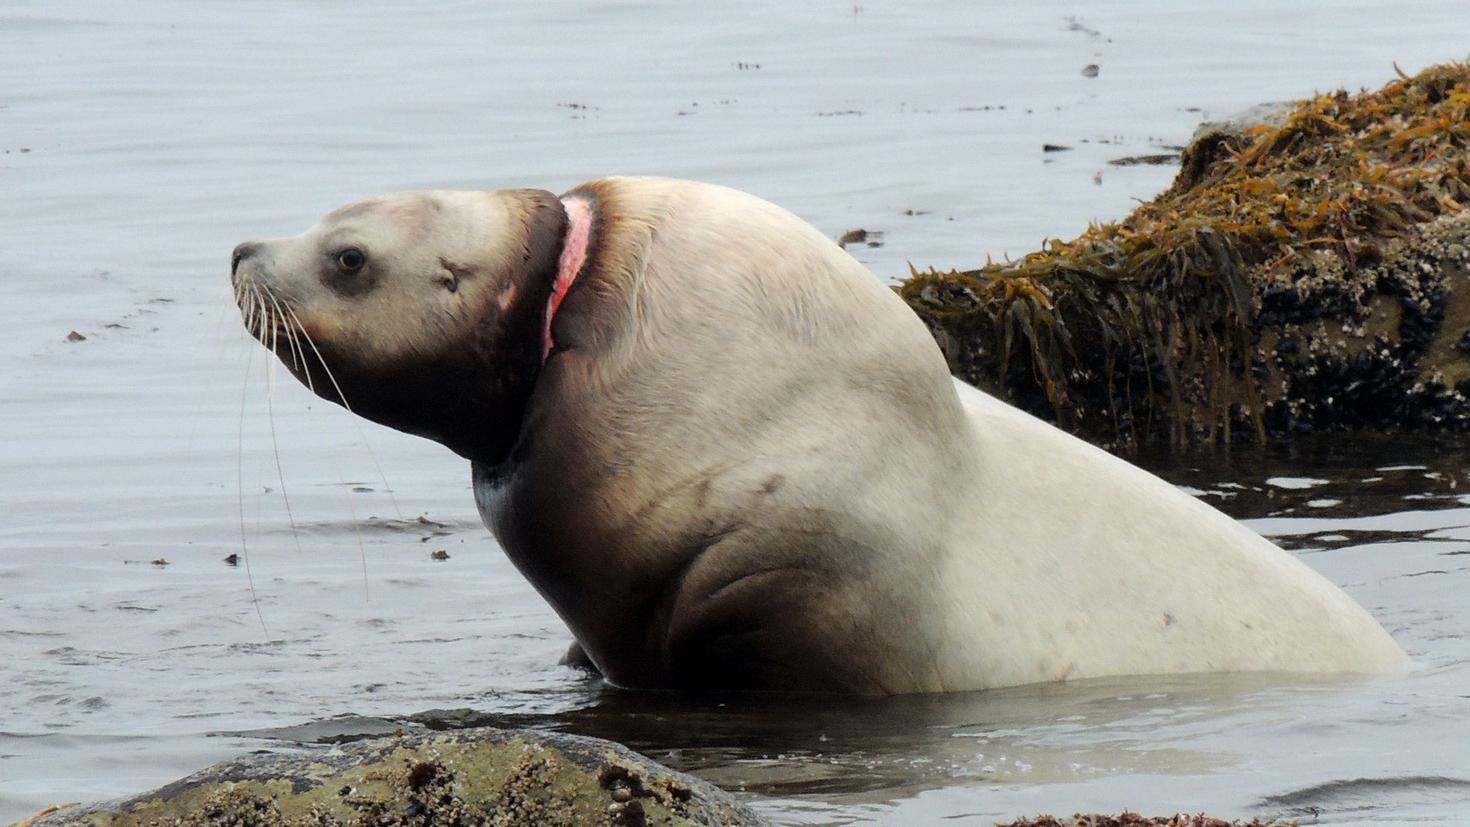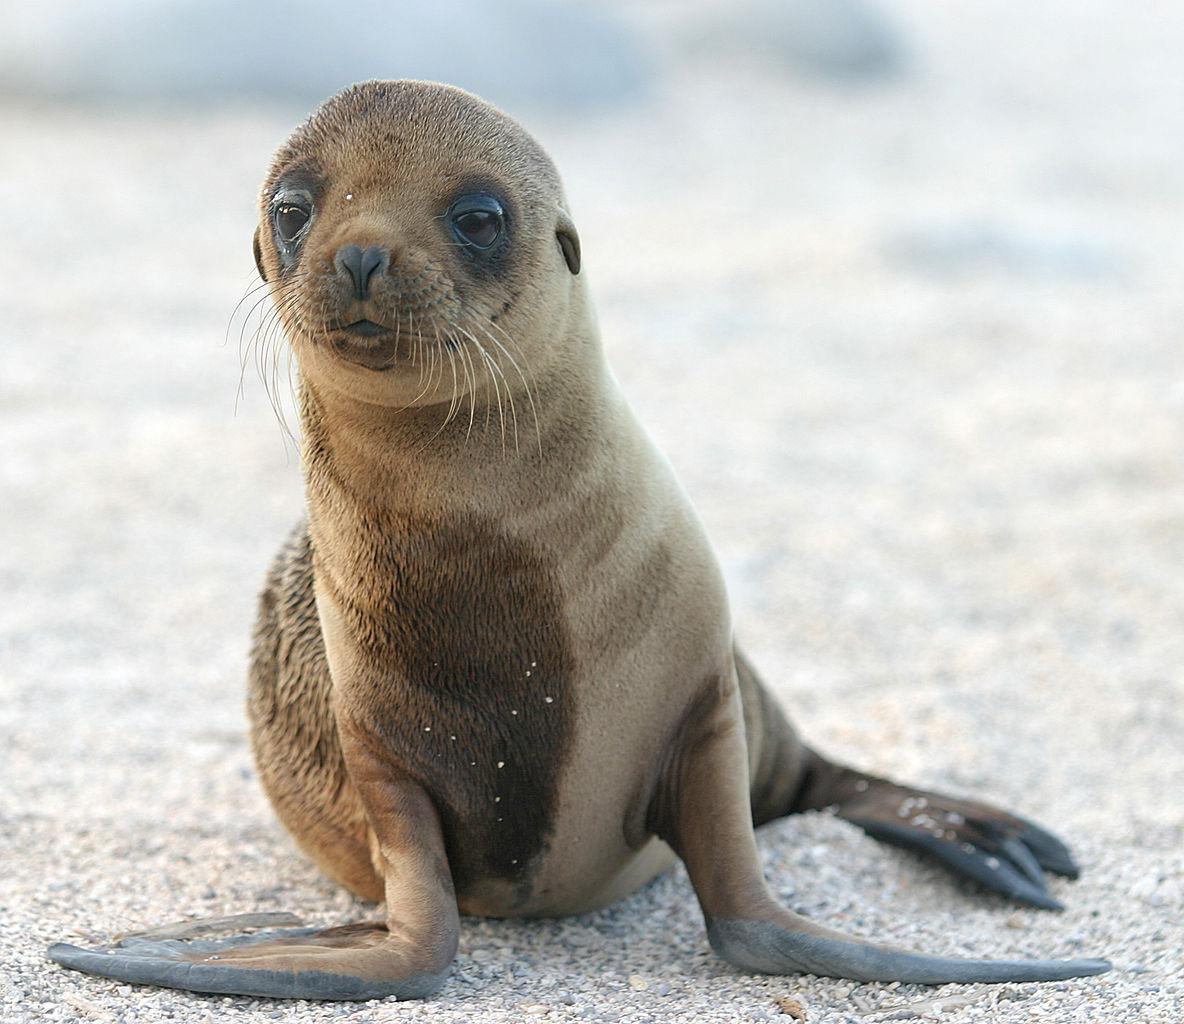The first image is the image on the left, the second image is the image on the right. Assess this claim about the two images: "An image shows exactly one seal, with flippers on a surface in front of its body.". Correct or not? Answer yes or no. Yes. The first image is the image on the left, the second image is the image on the right. For the images displayed, is the sentence "At least one of the images shows only one sea lion." factually correct? Answer yes or no. Yes. 